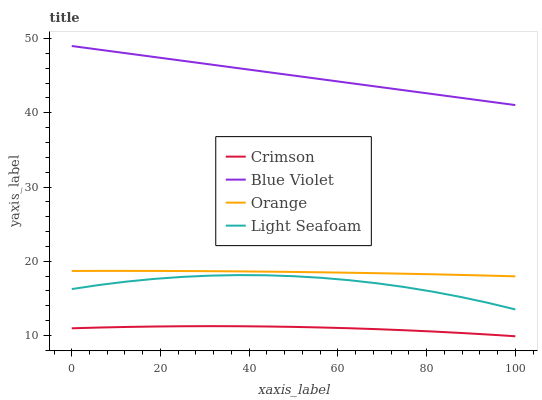Does Crimson have the minimum area under the curve?
Answer yes or no. Yes. Does Blue Violet have the maximum area under the curve?
Answer yes or no. Yes. Does Orange have the minimum area under the curve?
Answer yes or no. No. Does Orange have the maximum area under the curve?
Answer yes or no. No. Is Blue Violet the smoothest?
Answer yes or no. Yes. Is Light Seafoam the roughest?
Answer yes or no. Yes. Is Orange the smoothest?
Answer yes or no. No. Is Orange the roughest?
Answer yes or no. No. Does Orange have the lowest value?
Answer yes or no. No. Does Orange have the highest value?
Answer yes or no. No. Is Crimson less than Light Seafoam?
Answer yes or no. Yes. Is Blue Violet greater than Orange?
Answer yes or no. Yes. Does Crimson intersect Light Seafoam?
Answer yes or no. No. 